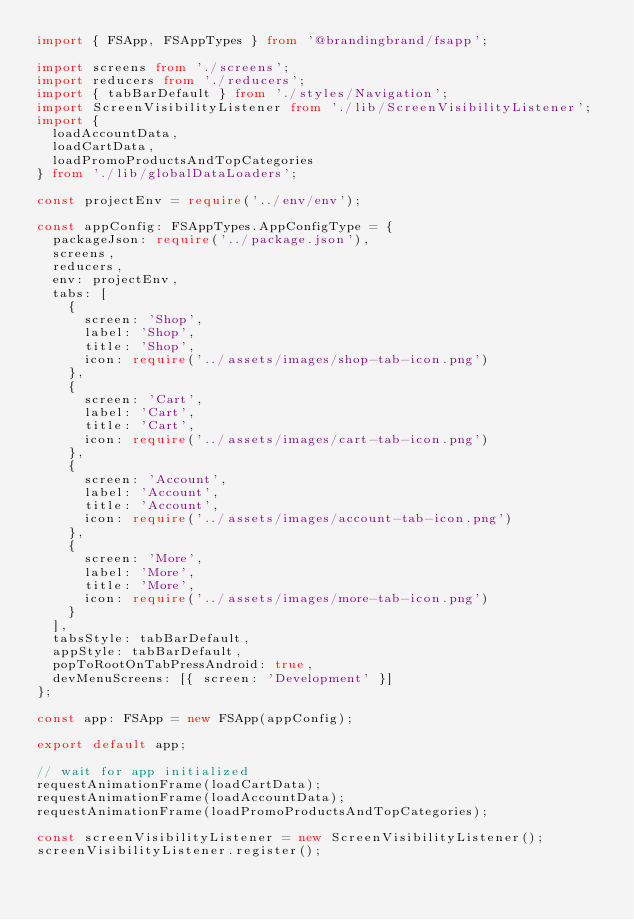Convert code to text. <code><loc_0><loc_0><loc_500><loc_500><_TypeScript_>import { FSApp, FSAppTypes } from '@brandingbrand/fsapp';

import screens from './screens';
import reducers from './reducers';
import { tabBarDefault } from './styles/Navigation';
import ScreenVisibilityListener from './lib/ScreenVisibilityListener';
import {
  loadAccountData,
  loadCartData,
  loadPromoProductsAndTopCategories
} from './lib/globalDataLoaders';

const projectEnv = require('../env/env');

const appConfig: FSAppTypes.AppConfigType = {
  packageJson: require('../package.json'),
  screens,
  reducers,
  env: projectEnv,
  tabs: [
    {
      screen: 'Shop',
      label: 'Shop',
      title: 'Shop',
      icon: require('../assets/images/shop-tab-icon.png')
    },
    {
      screen: 'Cart',
      label: 'Cart',
      title: 'Cart',
      icon: require('../assets/images/cart-tab-icon.png')
    },
    {
      screen: 'Account',
      label: 'Account',
      title: 'Account',
      icon: require('../assets/images/account-tab-icon.png')
    },
    {
      screen: 'More',
      label: 'More',
      title: 'More',
      icon: require('../assets/images/more-tab-icon.png')
    }
  ],
  tabsStyle: tabBarDefault,
  appStyle: tabBarDefault,
  popToRootOnTabPressAndroid: true,
  devMenuScreens: [{ screen: 'Development' }]
};

const app: FSApp = new FSApp(appConfig);

export default app;

// wait for app initialized
requestAnimationFrame(loadCartData);
requestAnimationFrame(loadAccountData);
requestAnimationFrame(loadPromoProductsAndTopCategories);

const screenVisibilityListener = new ScreenVisibilityListener();
screenVisibilityListener.register();
</code> 